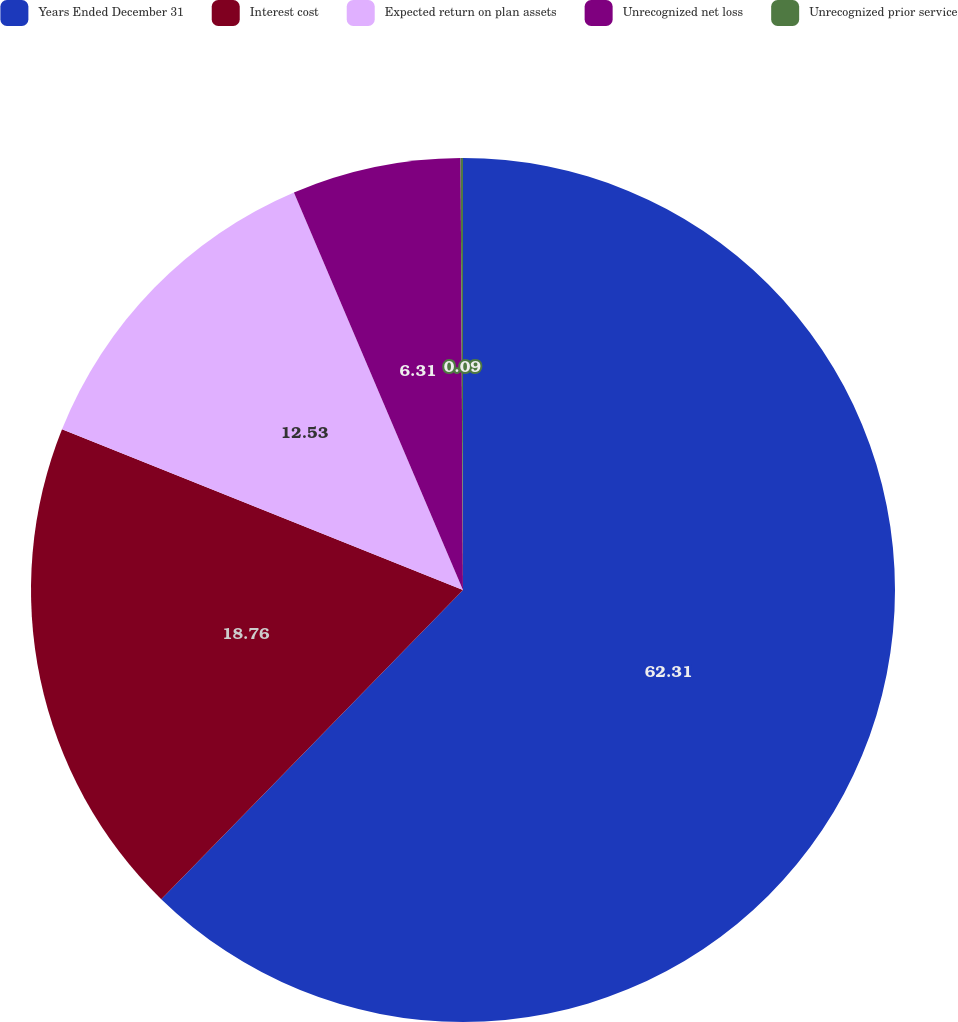Convert chart to OTSL. <chart><loc_0><loc_0><loc_500><loc_500><pie_chart><fcel>Years Ended December 31<fcel>Interest cost<fcel>Expected return on plan assets<fcel>Unrecognized net loss<fcel>Unrecognized prior service<nl><fcel>62.3%<fcel>18.76%<fcel>12.53%<fcel>6.31%<fcel>0.09%<nl></chart> 